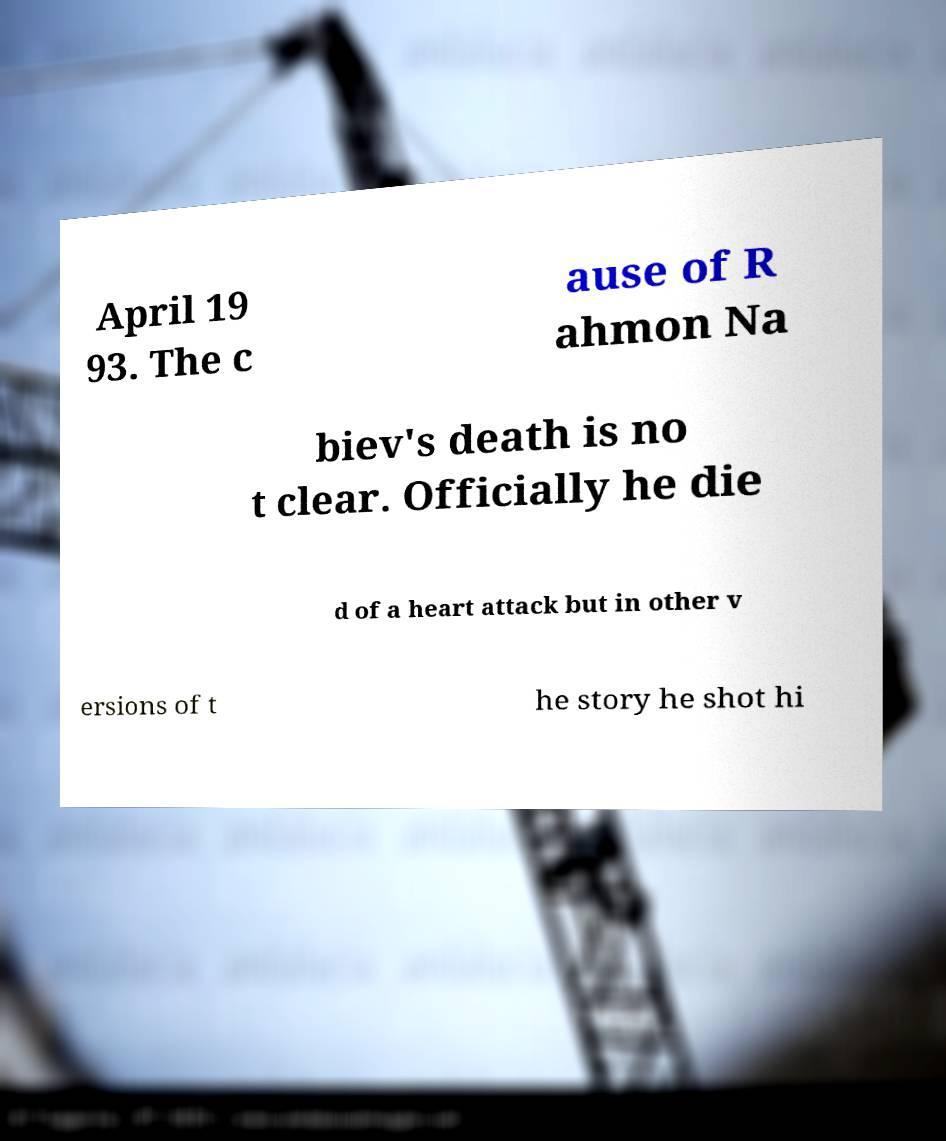Please read and relay the text visible in this image. What does it say? April 19 93. The c ause of R ahmon Na biev's death is no t clear. Officially he die d of a heart attack but in other v ersions of t he story he shot hi 